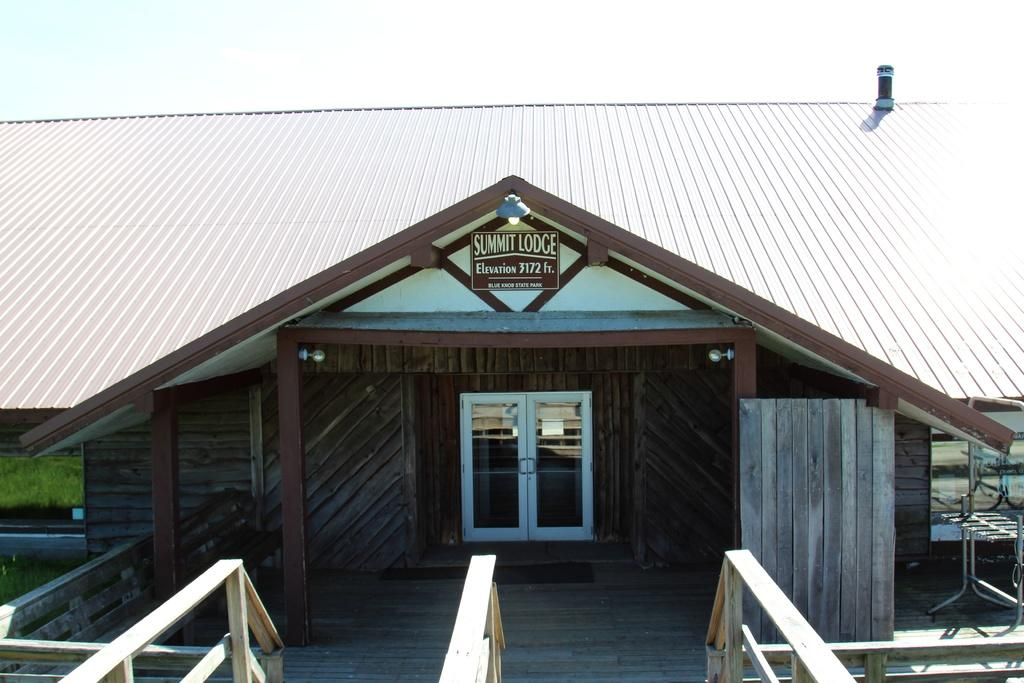What type of structure is in the image? There is a building in the image. Where is the building located in relation to the image? The building is at the front of the image. What type of vegetation is present beside the building? There is grass on the surface beside the building. What can be seen in the background of the image? The sky is visible in the background of the image. What statement does the boy make about the chess game in the image? There is no boy or chess game present in the image. 